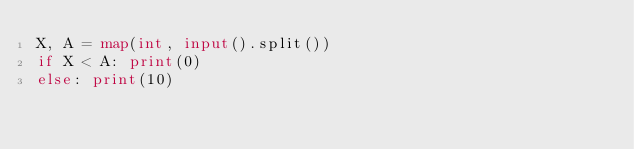<code> <loc_0><loc_0><loc_500><loc_500><_Python_>X, A = map(int, input().split())
if X < A: print(0)
else: print(10)</code> 